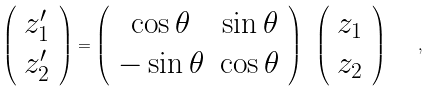Convert formula to latex. <formula><loc_0><loc_0><loc_500><loc_500>\left ( \begin{array} { c } z ^ { \prime } _ { 1 } \\ z ^ { \prime } _ { 2 } \end{array} \right ) = \left ( \begin{array} { c c } \cos \theta & \sin \theta \\ - \sin \theta & \cos \theta \end{array} \right ) \ \left ( \begin{array} { c } z _ { 1 } \\ z _ { 2 } \end{array} \right ) \quad ,</formula> 